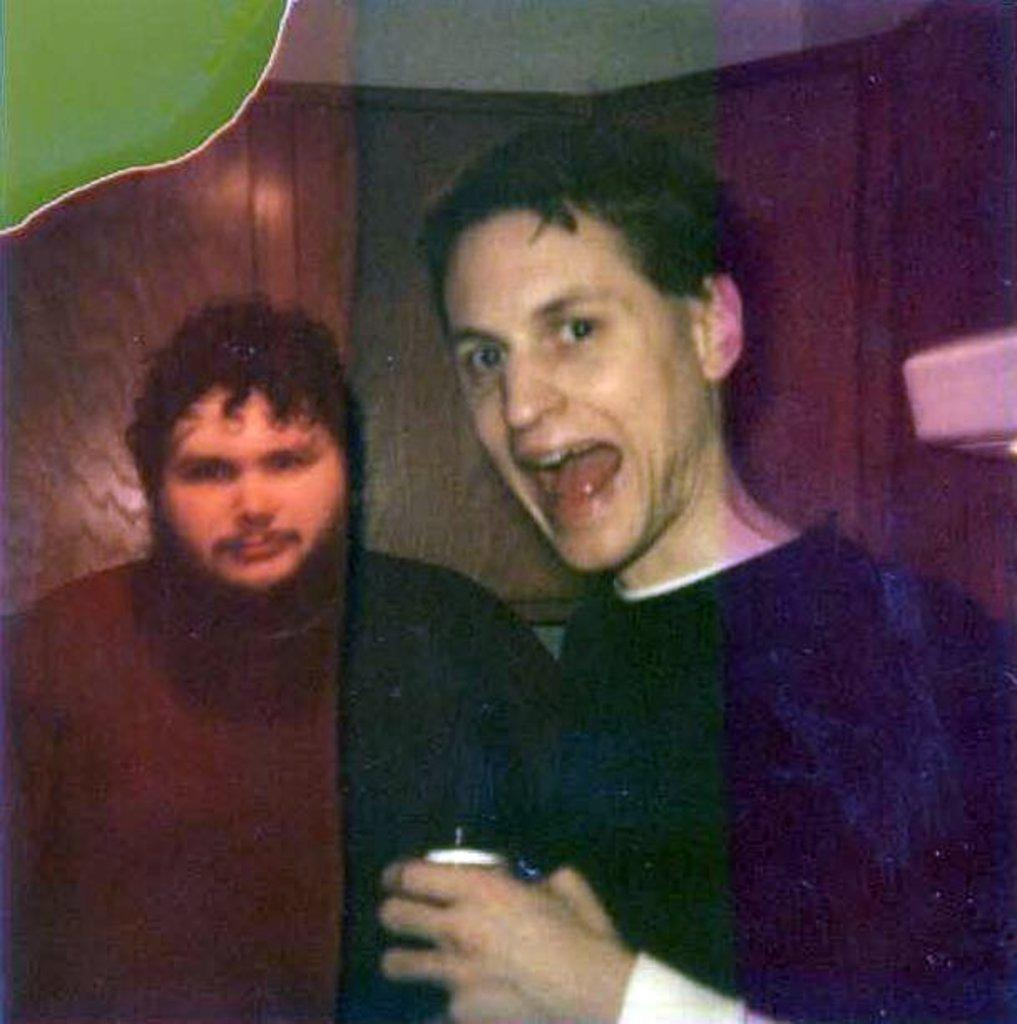How many people are in the image? There are two men in the image. What is the man on the right side holding? The man on the right side is holding something. What can be seen in the background of the image? There is a wall in the background of the image. What type of slope can be seen in the image? There is no slope present in the image. What is the man on the left side doing in the image? The provided facts do not mention the man on the left side or his actions, so we cannot answer this question definitively. 